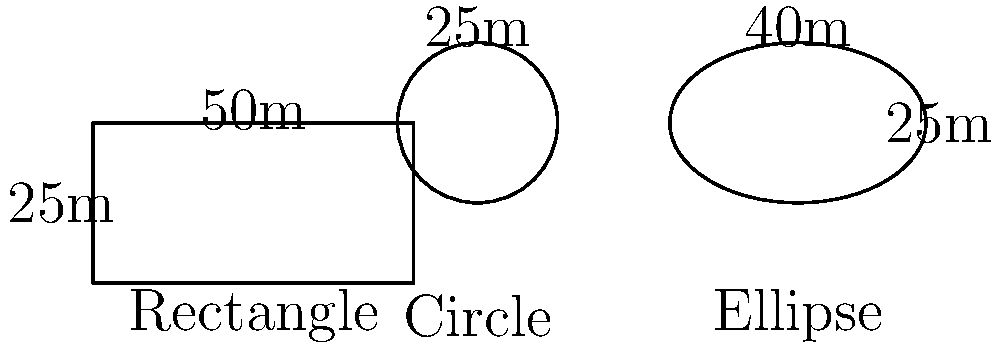As a swim coach designing a multi-purpose aquatic facility, you're considering three pool shapes for different swimming strokes: rectangular (50m x 25m), circular (25m diameter), and elliptical (40m x 25m). Calculate the total surface area of water if all three pools are constructed. Which shape provides the largest area for swimmers, and how much larger is it compared to the smallest? Let's calculate the area of each pool:

1. Rectangular pool:
   Area = length × width
   $A_r = 50 \text{ m} \times 25 \text{ m} = 1250 \text{ m}^2$

2. Circular pool:
   Area = $\pi r^2$, where $r = 12.5 \text{ m}$ (half of the diameter)
   $A_c = \pi \times (12.5 \text{ m})^2 \approx 490.87 \text{ m}^2$

3. Elliptical pool:
   Area = $\pi ab$, where $a = 20 \text{ m}$ and $b = 12.5 \text{ m}$ (half of each axis)
   $A_e = \pi \times 20 \text{ m} \times 12.5 \text{ m} \approx 785.40 \text{ m}^2$

Total surface area:
$A_{total} = A_r + A_c + A_e = 1250 + 490.87 + 785.40 = 2526.27 \text{ m}^2$

The largest area is the rectangular pool (1250 m²), and the smallest is the circular pool (490.87 m²).

Difference between largest and smallest:
$1250 \text{ m}^2 - 490.87 \text{ m}^2 = 759.13 \text{ m}^2$

Percentage difference:
$\frac{759.13 \text{ m}^2}{490.87 \text{ m}^2} \times 100\% \approx 154.65\%$

The rectangular pool is approximately 154.65% larger than the circular pool.
Answer: Total area: 2526.27 m². Rectangular pool largest, 154.65% larger than circular pool. 